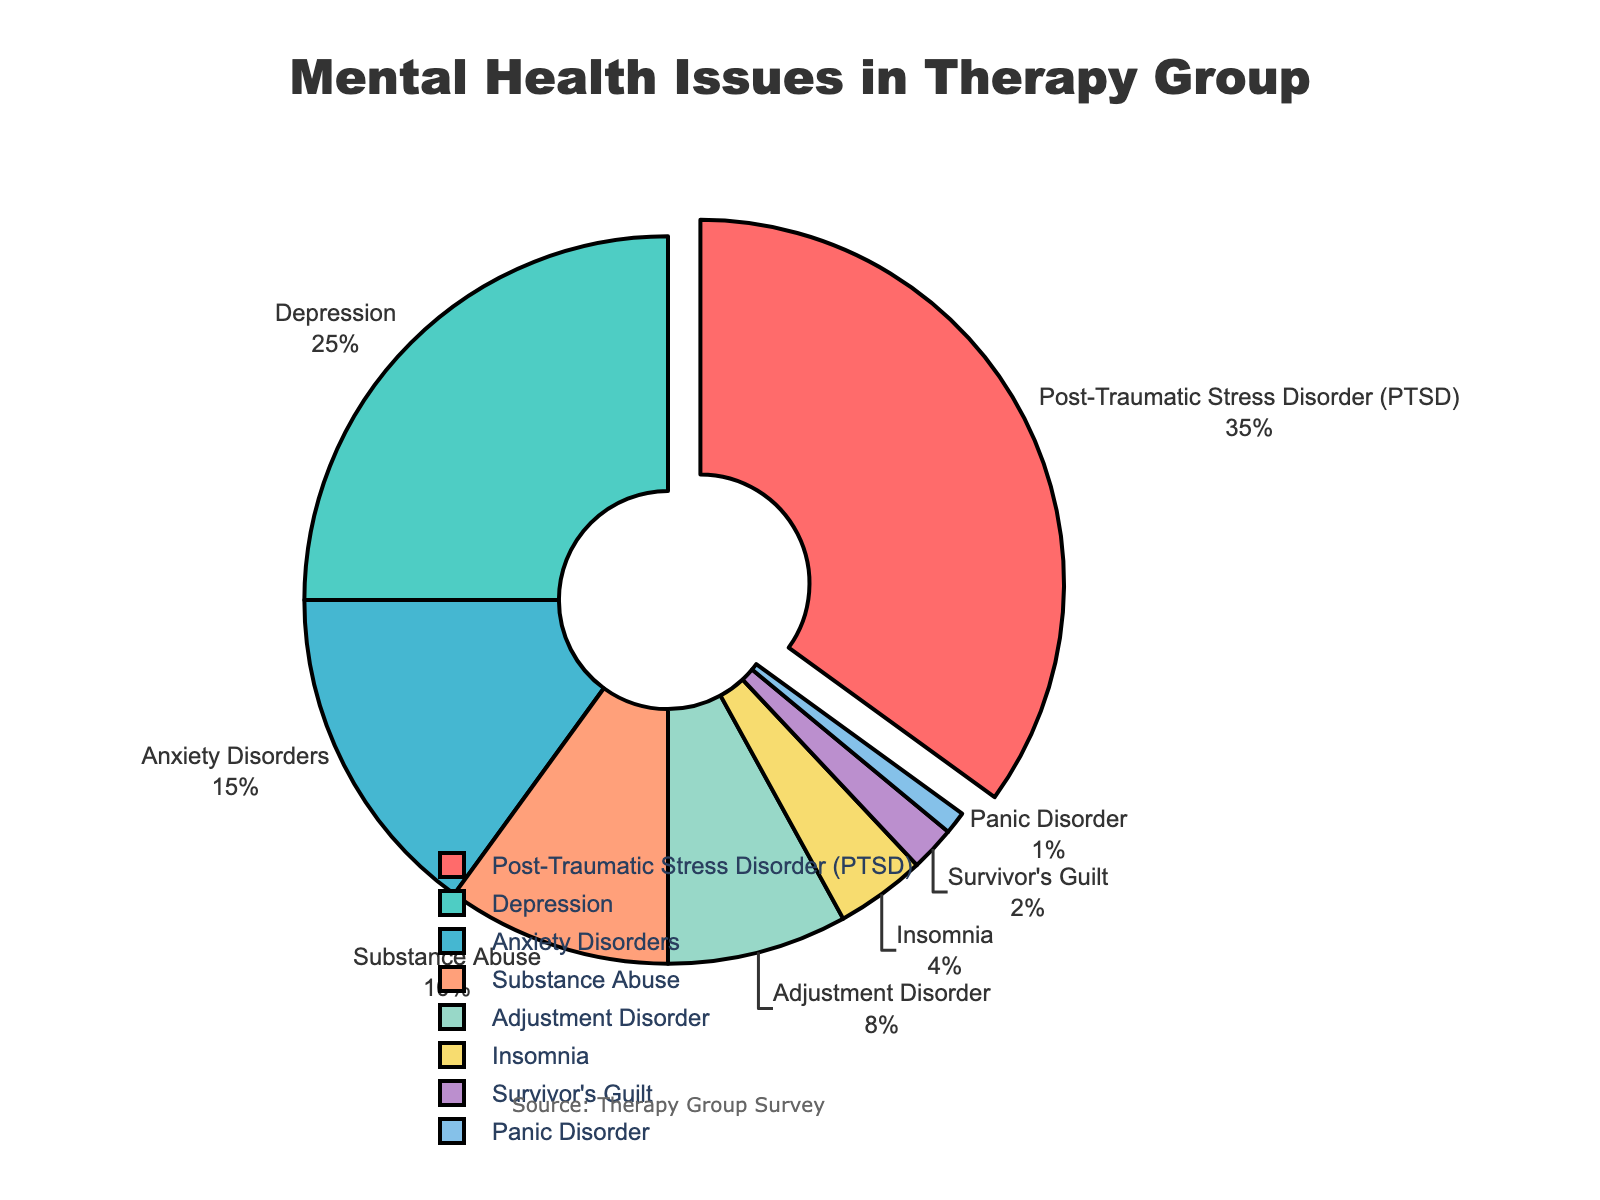What percentage of therapy group members experience PTSD? The chart shows each mental health issue with its corresponding percentage. Find "Post-Traumatic Stress Disorder (PTSD)" and note its value.
Answer: 35% What is the combined percentage of members experiencing Depression and Anxiety Disorders? Locate the percentages for "Depression" and "Anxiety Disorders" on the chart, which are 25% and 15%, respectively. Add them together: 25% + 15% = 40%.
Answer: 40% Which mental health issue has the smallest group of members experiencing it? Look for the mental health issue with the smallest percentage value. "Panic Disorder" has the smallest percentage at 1%.
Answer: Panic Disorder How much larger is the percentage of members experiencing PTSD compared to those with Insomnia? Find the percentages of "PTSD" (35%) and "Insomnia" (4%). Subtract the Insomnia percentage from the PTSD percentage: 35% - 4% = 31%.
Answer: 31% What is the total percentage of members dealing with Substance Abuse and Survivor's Guilt? Check the chart for the percentages of "Substance Abuse" (10%) and "Survivor's Guilt" (2%). Add these values together: 10% + 2% = 12%.
Answer: 12% Which mental health issue is highlighted (pulled out) from the pie chart? Observe the visual presentation and identify which section of the pie chart is pulled out. The chart highlights "Post-Traumatic Stress Disorder (PTSD)".
Answer: Post-Traumatic Stress Disorder (PTSD) Which two issues have the closest percentages, and what is the difference between them? Compare the percentages and find that "Insomnia" (4%) and "Survivor's Guilt" (2%) are closest. Calculate the difference: 4% - 2% = 2%.
Answer: Insomnia and Survivor's Guilt, 2% What percentage of the therapy group members experience mental health issues other than PTSD? Subtract the percentage of PTSD from 100%: 100% - 35% = 65%.
Answer: 65% How does the percentage of members with Adjustment Disorder compare to those with Substance Abuse? Find the percentages for "Adjustment Disorder" (8%) and "Substance Abuse" (10%). Since 8% is less than 10%, members with Adjustment Disorder are fewer.
Answer: Less (8% vs. 10%) What issues affect more than 20% of the members? Identify the issues with percentages greater than 20%: "PTSD" (35%) and "Depression" (25%).
Answer: PTSD and Depression 